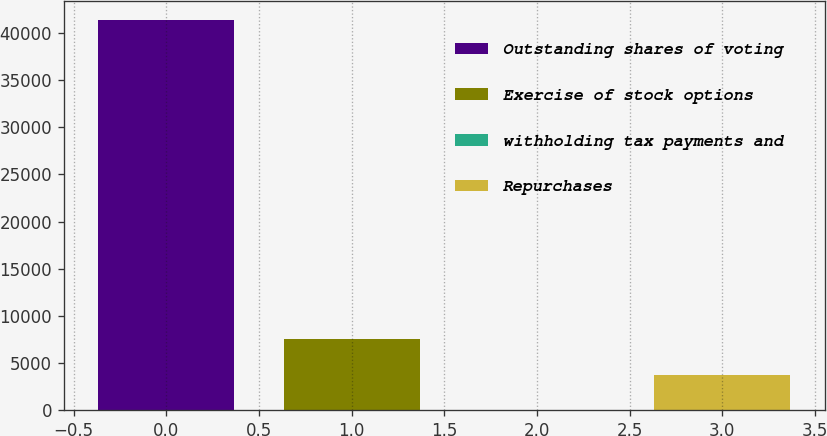<chart> <loc_0><loc_0><loc_500><loc_500><bar_chart><fcel>Outstanding shares of voting<fcel>Exercise of stock options<fcel>withholding tax payments and<fcel>Repurchases<nl><fcel>41302.2<fcel>7555.4<fcel>39<fcel>3797.2<nl></chart> 